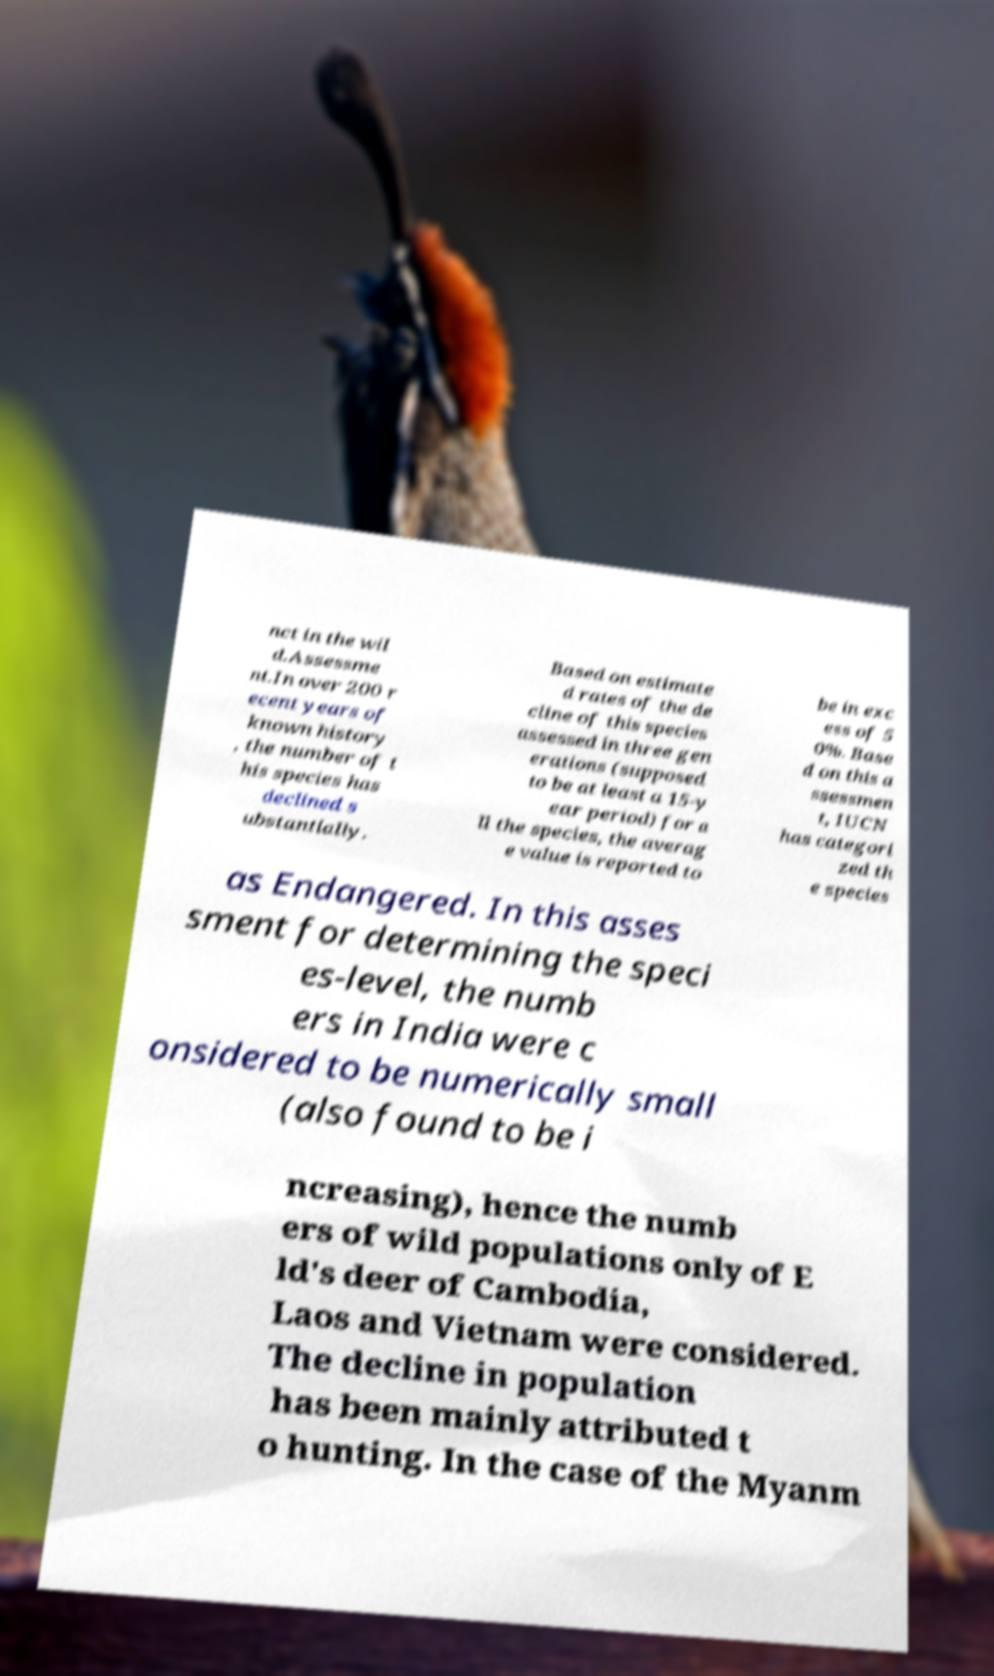Can you read and provide the text displayed in the image?This photo seems to have some interesting text. Can you extract and type it out for me? nct in the wil d.Assessme nt.In over 200 r ecent years of known history , the number of t his species has declined s ubstantially. Based on estimate d rates of the de cline of this species assessed in three gen erations (supposed to be at least a 15-y ear period) for a ll the species, the averag e value is reported to be in exc ess of 5 0%. Base d on this a ssessmen t, IUCN has categori zed th e species as Endangered. In this asses sment for determining the speci es-level, the numb ers in India were c onsidered to be numerically small (also found to be i ncreasing), hence the numb ers of wild populations only of E ld's deer of Cambodia, Laos and Vietnam were considered. The decline in population has been mainly attributed t o hunting. In the case of the Myanm 